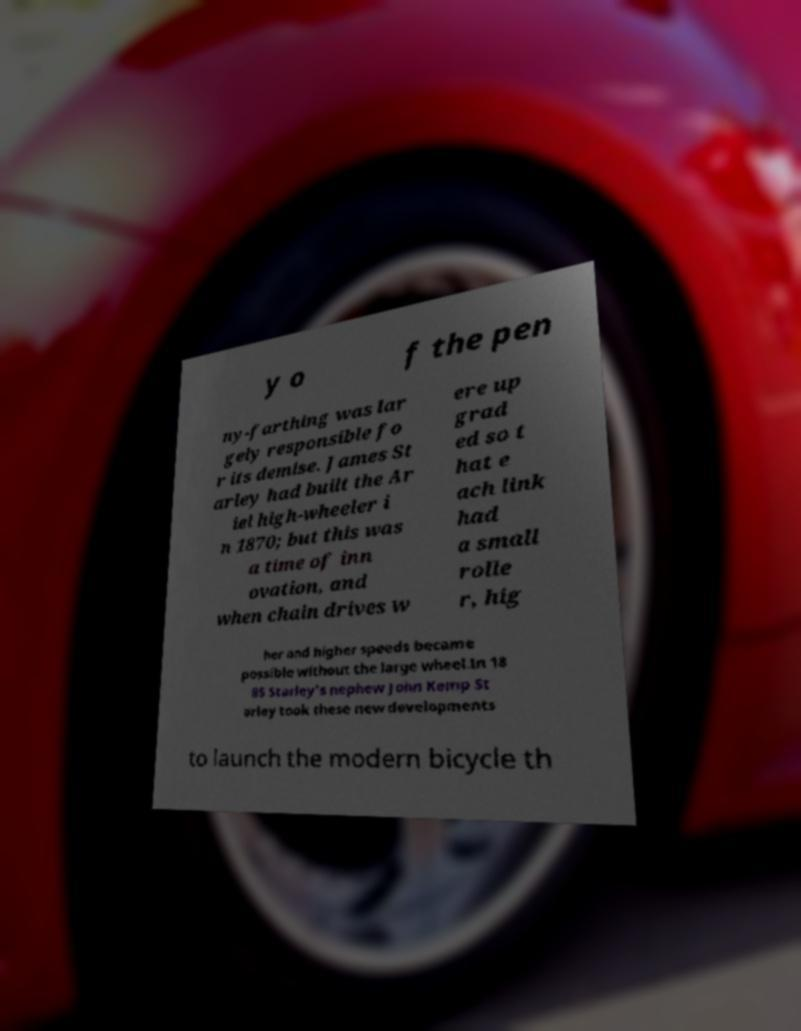Please read and relay the text visible in this image. What does it say? y o f the pen ny-farthing was lar gely responsible fo r its demise. James St arley had built the Ar iel high-wheeler i n 1870; but this was a time of inn ovation, and when chain drives w ere up grad ed so t hat e ach link had a small rolle r, hig her and higher speeds became possible without the large wheel.In 18 85 Starley's nephew John Kemp St arley took these new developments to launch the modern bicycle th 